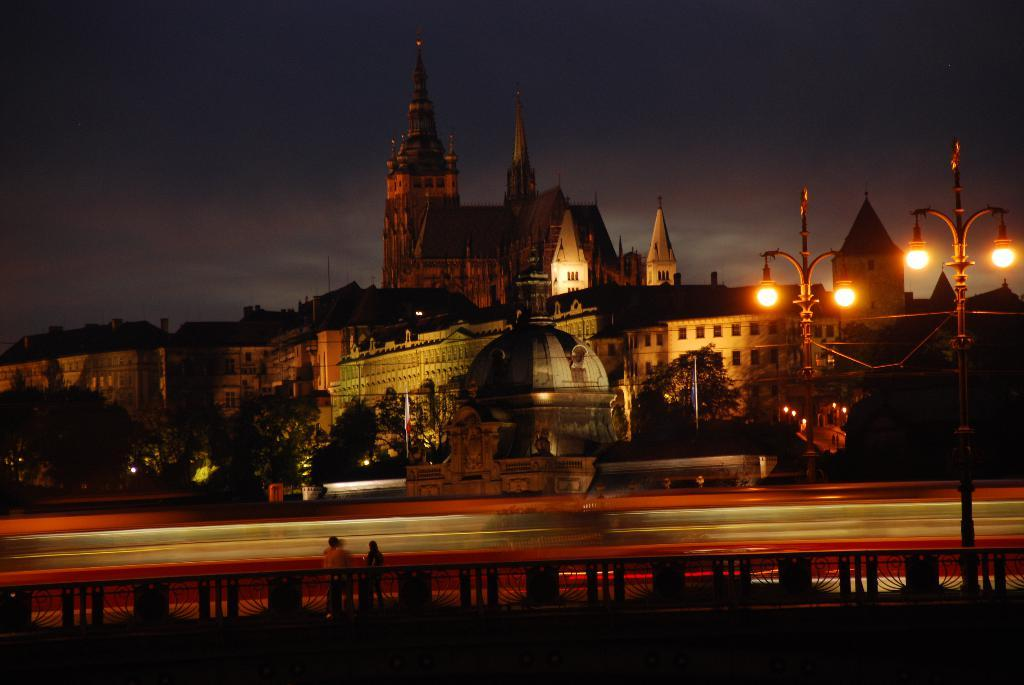What can be seen in the image? There are persons standing in the image. What structures are present in the image? There are light poles in the image. What can be seen in the distance in the image? There are buildings in the background of the image. What is the color of the sky in the image? The sky is blue and white in color. What type of secretary is sitting on the chair in the image? There is no secretary or chair present in the image. 